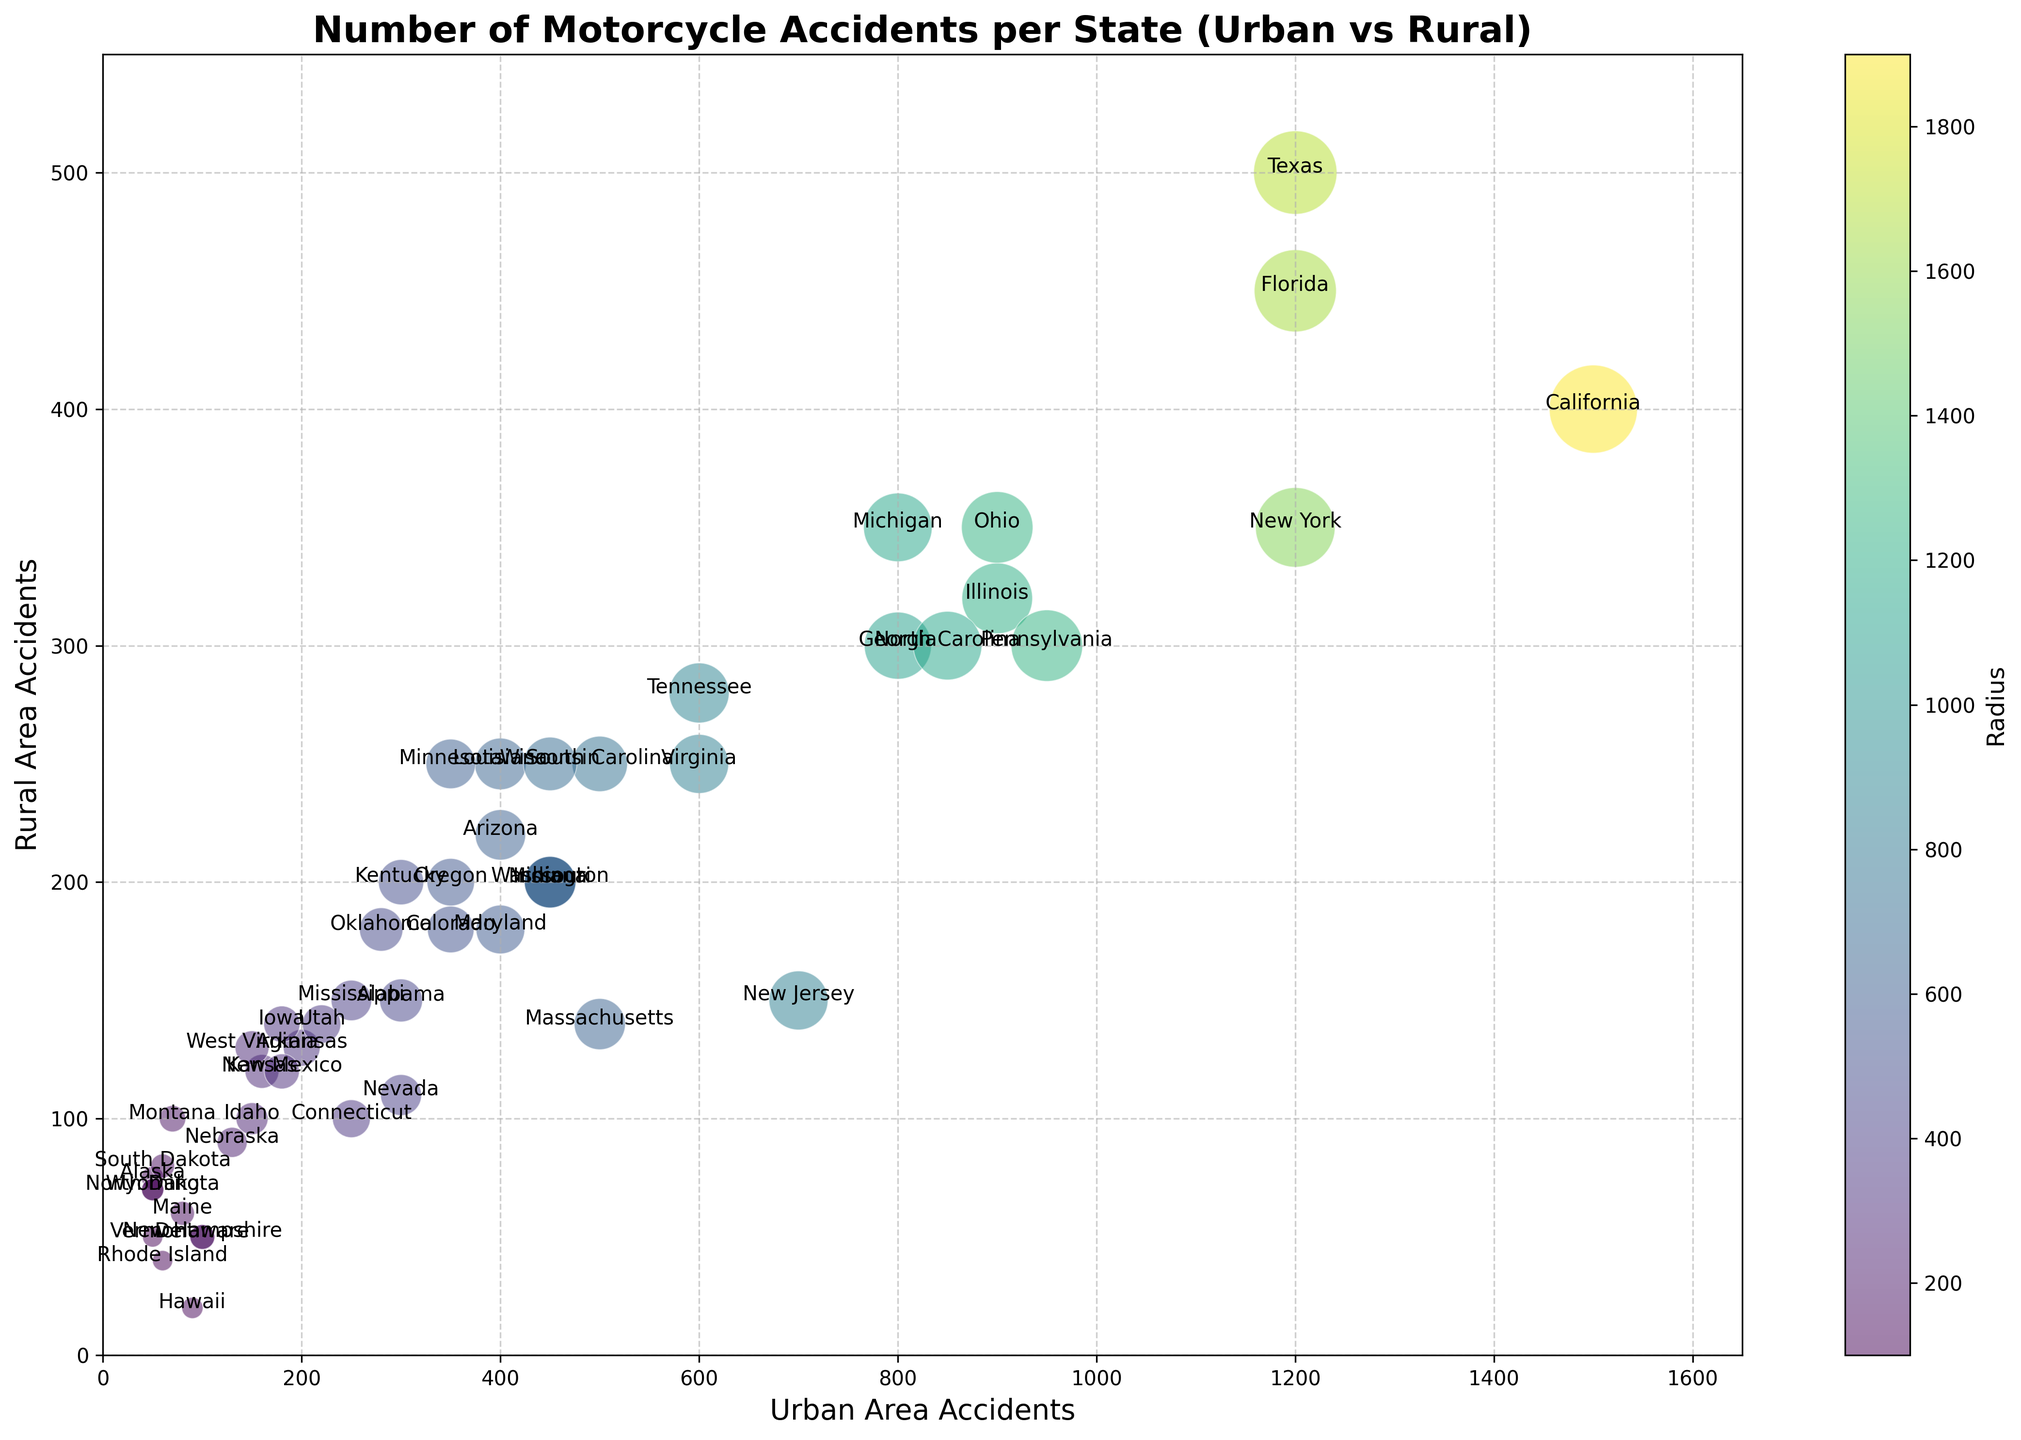Which state has the highest number of urban area accidents? By observing the figure, look for the bubble positioned furthest along the x-axis, which represents urban area accidents. California stands out as the furthest to the right on the x-axis.
Answer: California Which state has the largest difference between urban and rural area accidents? Compare the distances of bubbles along the x and y-axes and identify the largest gap. California has the most significant difference, visually having a much higher urban accident count compared to rural.
Answer: California What is the average number of rural area accidents for the states shown? Sum all rural area accident values and divide by the number of states. (150 + 75 + 220 + 130 + ... + 70) / 50 = 19025 / 50 = 380.5.
Answer: 380.5 Which state has the smallest radius representing the number of total accidents? Look for the smallest bubble in the plot. Rhode Island has the tiniest bubble, indicating the smallest total number of accidents.
Answer: Rhode Island How many states have more than 500 urban area accidents? Count the bubbles that are positioned to the right of the 500-mark on the x-axis. These are California, Florida, Georgia, Illinois, Michigan, New York, North Carolina, Ohio, Pennsylvania, and Texas. There are 10 states.
Answer: 10 What is the median value of total accidents among the states? Order the Radius values and locate the middle value. The median of 50 Radius values is between the 25th and 26th when sorted. The radii for these positions are near 360 and 400 respectively, so the median is around 380.
Answer: 380 Which state has the closest balance between urban and rural accidents? Look at bubbles closest to the diagonal line y = x, indicating equal urban and rural accidents. Vermont closely aligns with the diagonal, having nearly equal urban and rural accidents.
Answer: Vermont Is there a state with more rural accidents than urban accidents? Observe bubbles above the diagonal y = x line. No bubbles are above this line, meaning no state has more rural accidents than urban.
Answer: No Which state has the most rural area accidents? Find the bubble furthest up the y-axis. Texas stands out highest along the y-axis.
Answer: Texas What is the relationship between the radius of the bubbles and the number of total accidents? The larger the radius, the higher the number of total accidents it represents. This is illustrated by larger bubbles for states with high combined urban and rural accidents, like California and Florida.
Answer: Direct relationship 